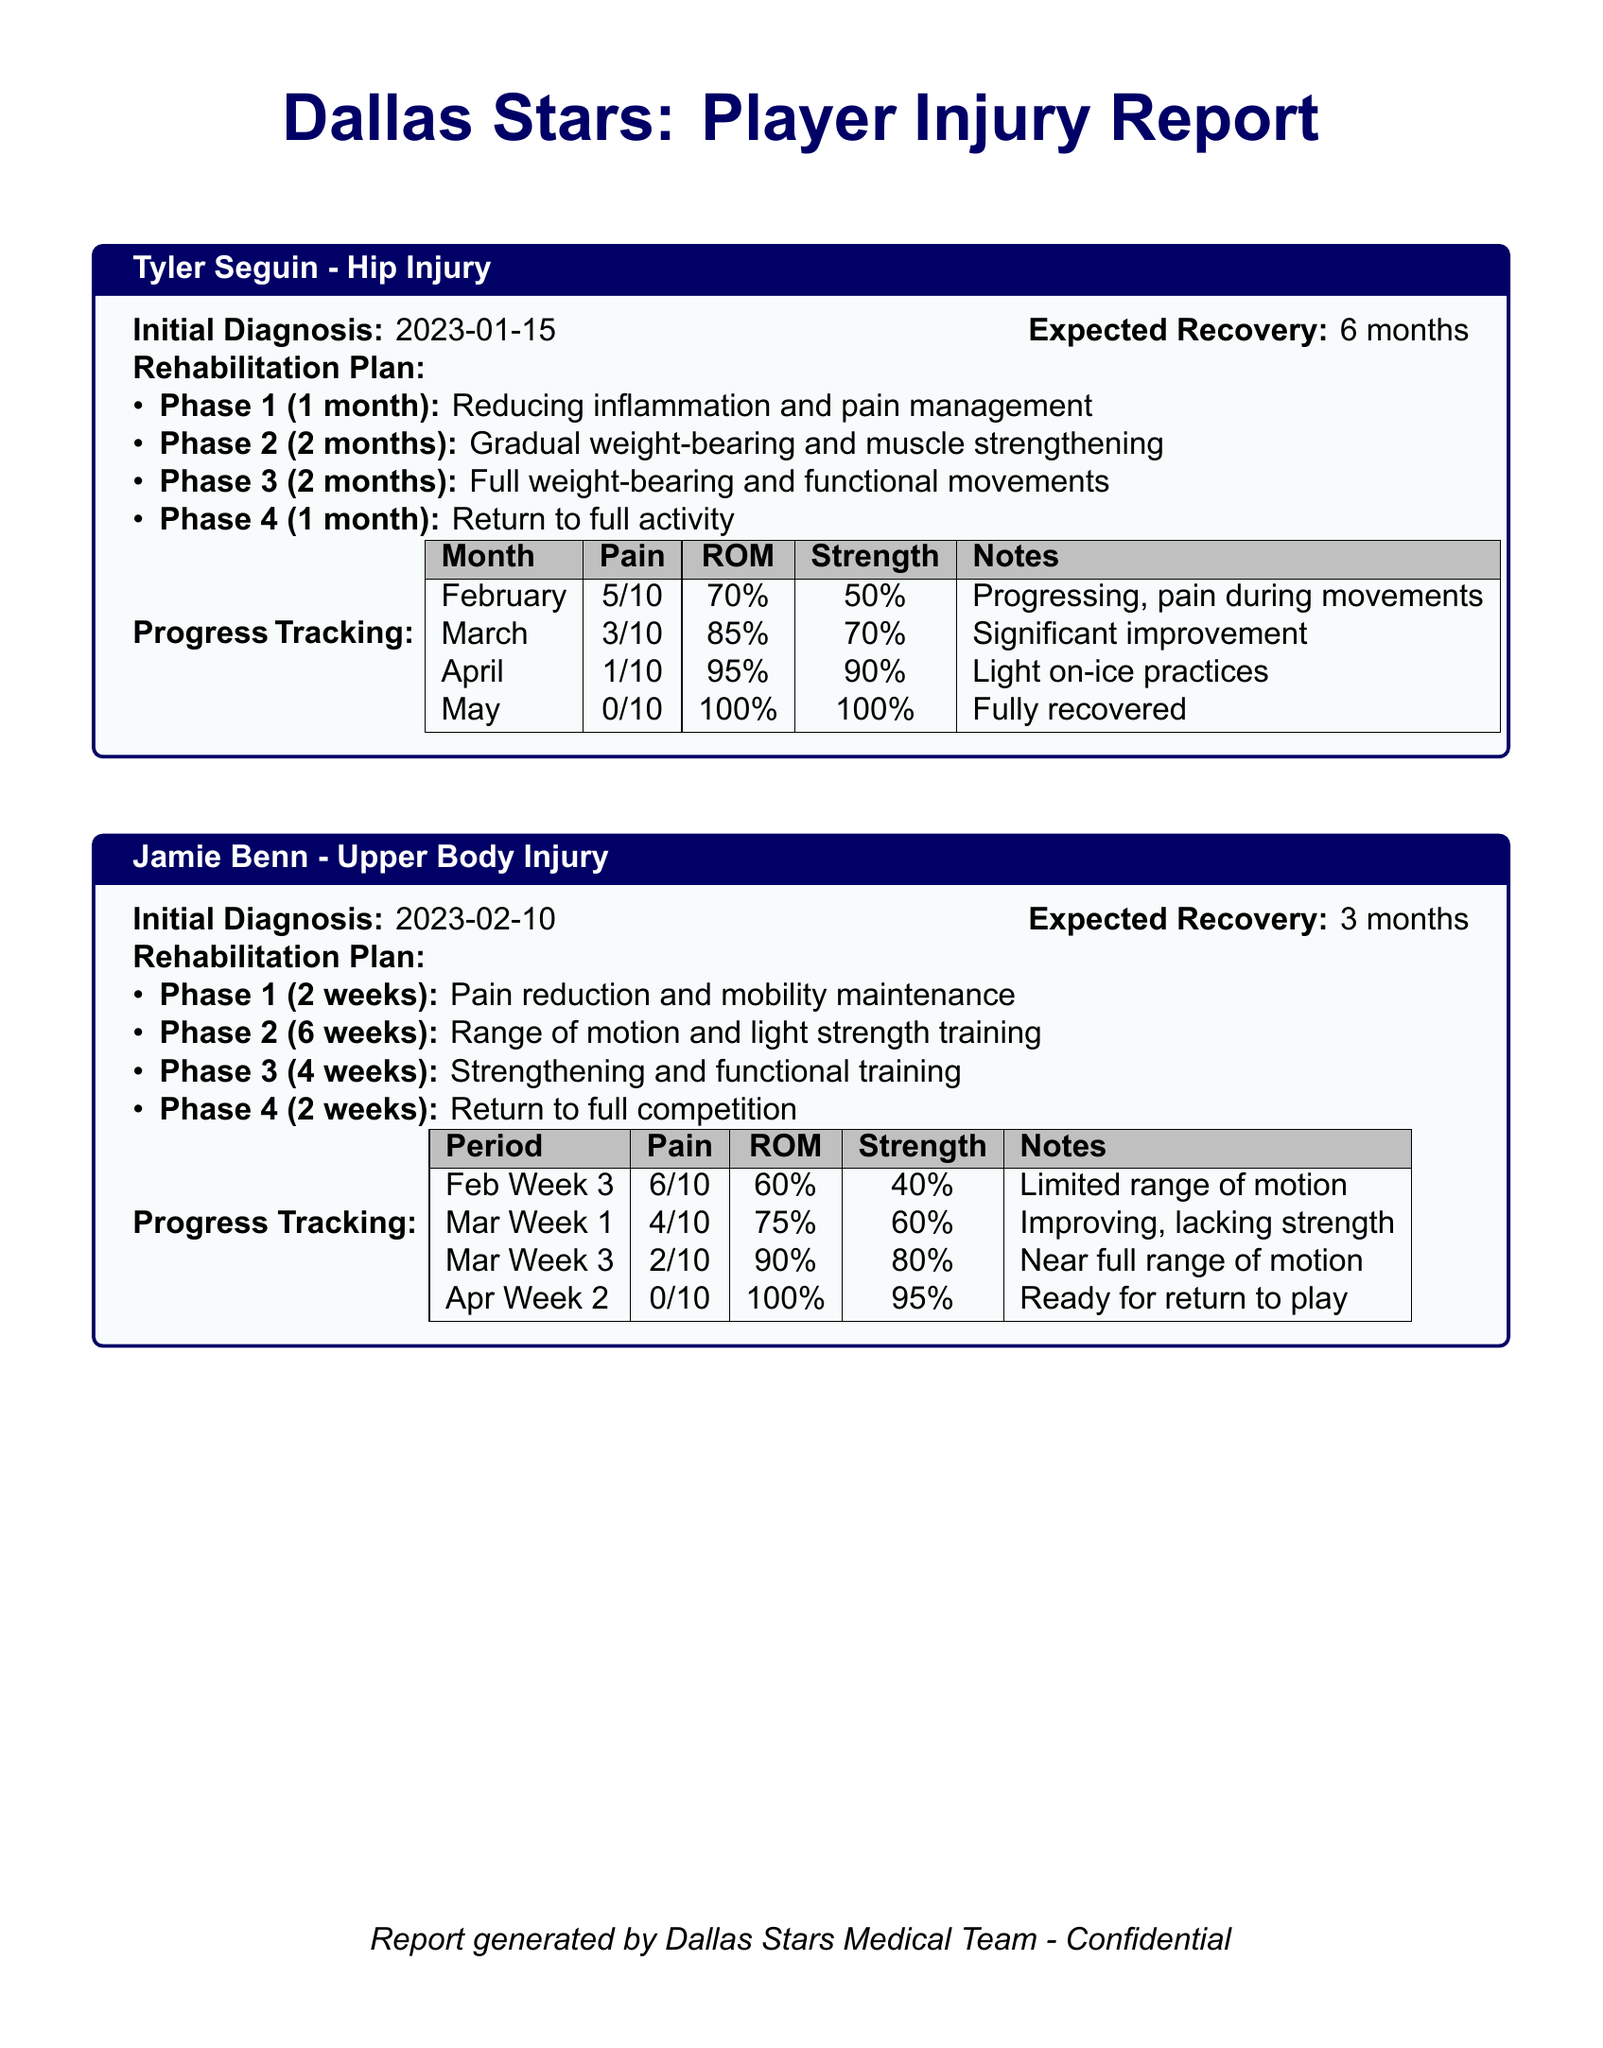what is Tyler Seguin's initial diagnosis date? The document states Tyler Seguin's initial diagnosis date as 2023-01-15.
Answer: 2023-01-15 what is Jamie Benn's expected recovery time? According to the document, Jamie Benn's expected recovery time is 3 months.
Answer: 3 months how many phases are in Tyler Seguin's rehabilitation plan? The rehabilitation plan for Tyler Seguin includes four phases as outlined in the document.
Answer: 4 what is the pain level for Tyler Seguin in March? The document indicates that Tyler Seguin's pain level in March is 3/10.
Answer: 3/10 what was Jamie Benn's range of motion in Mar Week 3? In Mar Week 3, Jamie Benn's range of motion was reported as 90%.
Answer: 90% what is the strength percentage for Tyler Seguin in May? The document shows that Tyler Seguin's strength percentage in May is 100%.
Answer: 100% what phase is Jamie Benn in during the second week of April? Jamie Benn is in Phase 4 during the second week of April, which is focused on returning to full competition.
Answer: Phase 4 what pain level does Tyler Seguin have in May? The document states that Tyler Seguin's pain level in May is 0/10.
Answer: 0/10 what is the recovery objective in Phase 3 for Jamie Benn? The objective in Phase 3 for Jamie Benn is strengthening and functional training.
Answer: Strengthening and functional training 